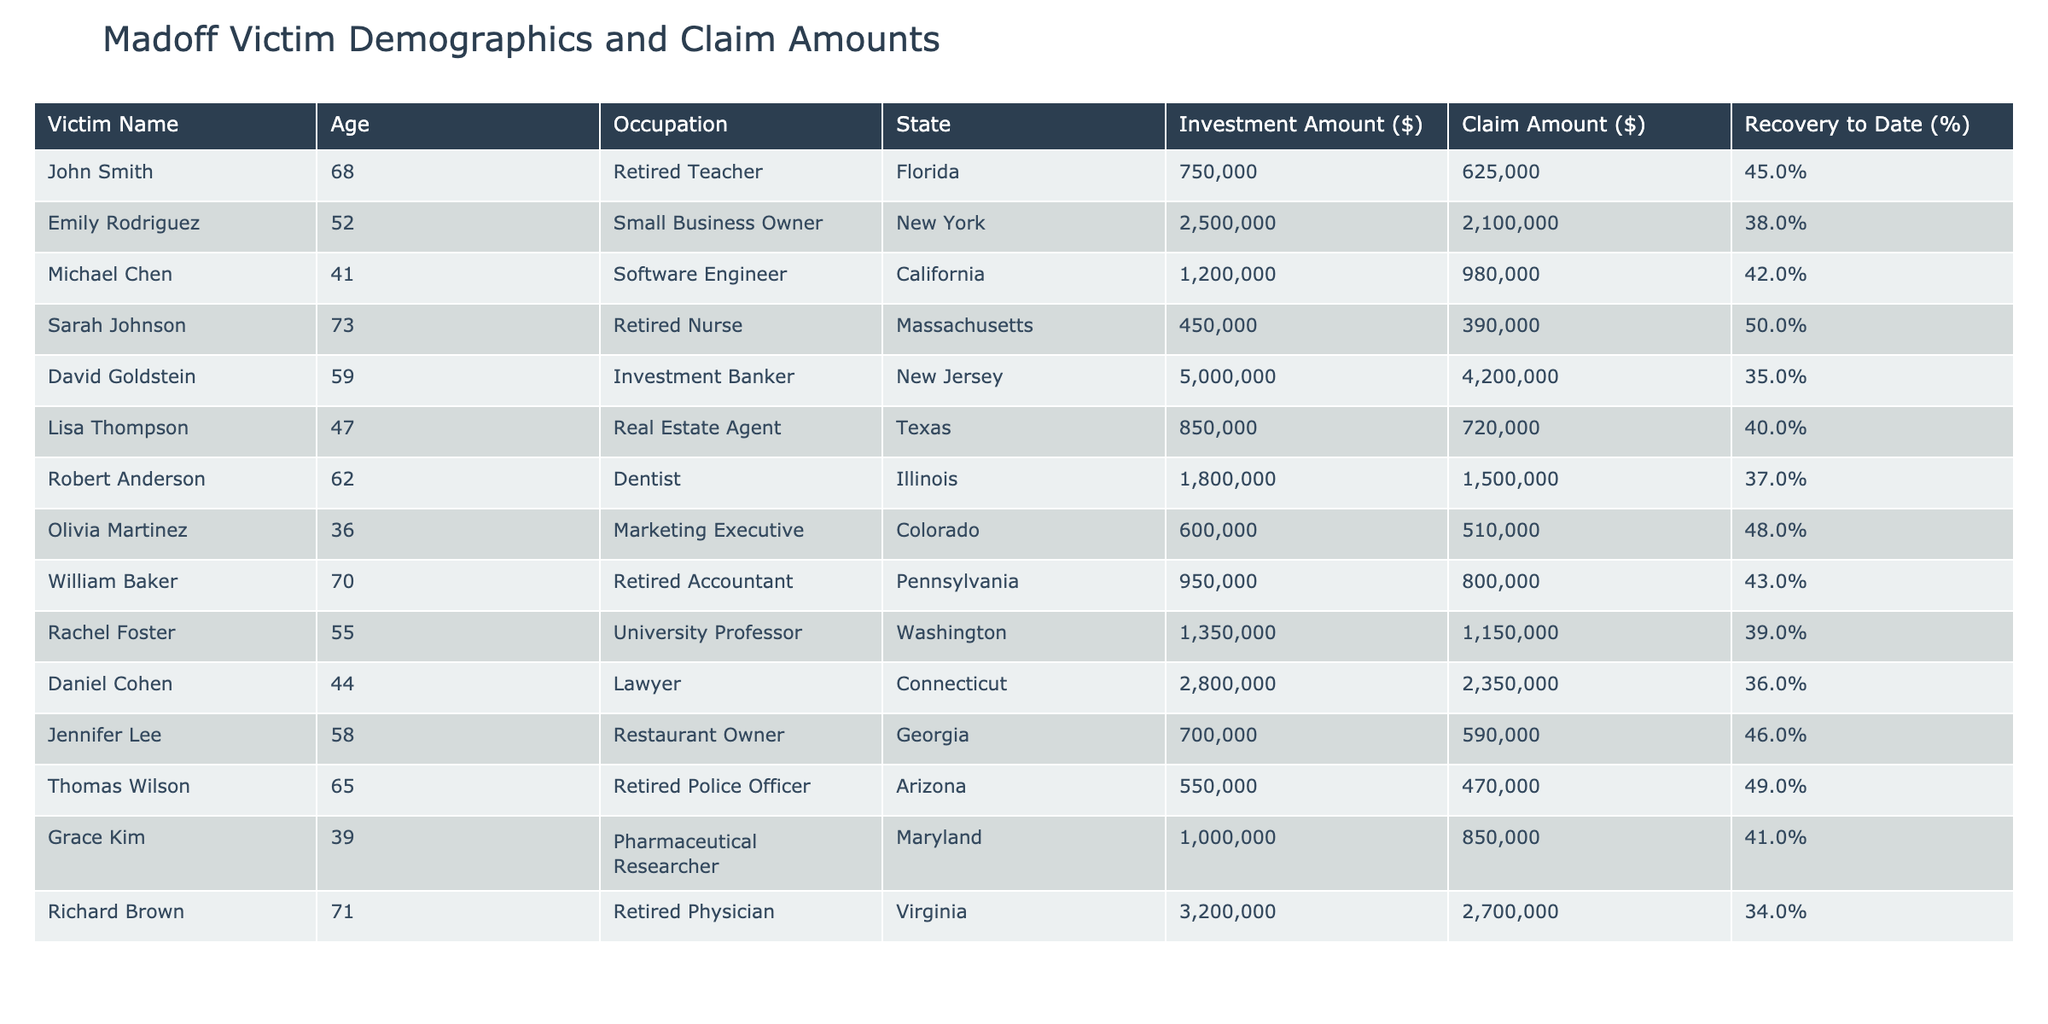What is the claim amount for Emily Rodriguez? Emily Rodriguez's claim amount is explicitly listed in the table under the 'Claim Amount ($)' column. It states the amount as $2,100,000.
Answer: 2,100,000 Which victim has the highest claim amount? By examining the 'Claim Amount ($)' column, David Goldstein has the highest claim amount at $4,200,000.
Answer: David Goldstein What is the average investment amount of all victims? To find the average investment amount, sum all investment amounts: 750,000 + 2,500,000 + 1,200,000 + 450,000 + 5,000,000 + 850,000 + 1,800,000 + 600,000 + 950,000 + 1,350,000 + 2,800,000 + 700,000 + 550,000 + 1,000,000 + 3,200,000 = 22,800,000. There are 14 victims, so the average investment amount is 22,800,000 / 14 = 1,628,571.43.
Answer: 1,628,571.43 What percentage recovery does Lisa Thompson have? The recovery percentage for each victim is found in the 'Recovery to Date (%)' column, and for Lisa Thompson, it is stated as 40%.
Answer: 40% Is there anyone from New Jersey whose recovery is less than 40%? Looking at the table, only David Goldstein from New Jersey is listed and has a recovery of 35%, which is indeed less than 40%.
Answer: Yes What is the total investment amount from victims aged 60 and above? The victims aged 60 and above are John Smith, Michael Chen, Robert Anderson, William Baker, Thomas Wilson, and Richard Brown. Their investment amounts are 750,000, 1,200,000, 1,800,000, 950,000, 550,000, and 3,200,000, respectively, giving a total of 750,000 + 1,200,000 + 1,800,000 + 950,000 + 550,000 + 3,200,000 = 8,450,000.
Answer: 8,450,000 What is the difference between the highest and lowest claim amounts? The highest claim amount is from David Goldstein at $4,200,000 and the lowest claim amount is from Olivia Martinez at $510,000. The difference is 4,200,000 - 510,000 = 3,690,000.
Answer: 3,690,000 Which state has the highest average claim amount? To find the average claim amount per state, sum the claim amounts for each state and divide by the number of victims from that state: Florida (625,000), New York (2,100,000), California (980,000), Massachusetts (390,000), New Jersey (4,200,000), Texas (720,000), Illinois (1,500,000), Colorado (510,000), Pennsylvania (800,000), Washington (1,150,000), Connecticut (2,350,000), Georgia (590,000), Arizona (470,000), Maryland (850,000), Virginia (2,700,000). After calculating for each state, New York has the highest average claim by far.
Answer: New York Are most victims retired individuals or those still working? By counting the occupations, retired individuals are identified as follows: John Smith, Sarah Johnson, William Baker, Thomas Wilson, and Richard Brown. The total is 5 retired individuals compared to the others, making a comparative analysis indicate that most victims are indeed retired.
Answer: Yes 